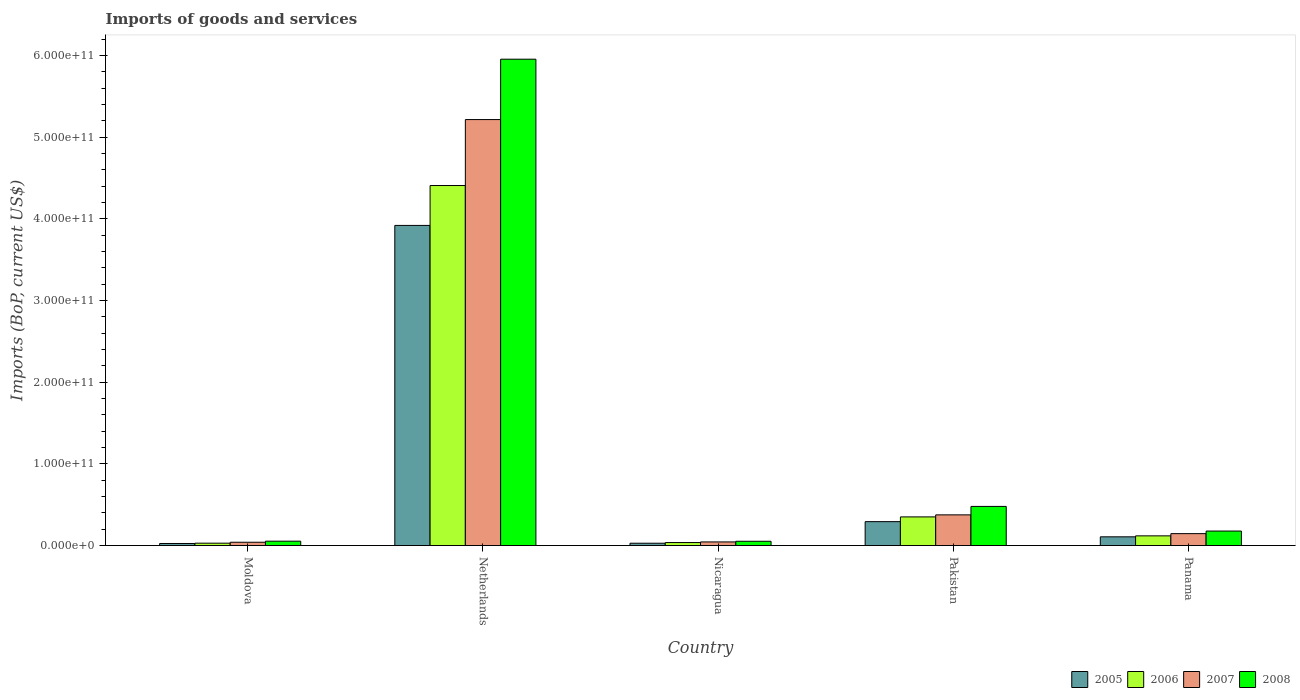How many different coloured bars are there?
Offer a very short reply. 4. How many groups of bars are there?
Your answer should be compact. 5. Are the number of bars per tick equal to the number of legend labels?
Make the answer very short. Yes. Are the number of bars on each tick of the X-axis equal?
Make the answer very short. Yes. How many bars are there on the 1st tick from the left?
Offer a very short reply. 4. What is the label of the 3rd group of bars from the left?
Give a very brief answer. Nicaragua. What is the amount spent on imports in 2007 in Nicaragua?
Provide a succinct answer. 4.45e+09. Across all countries, what is the maximum amount spent on imports in 2008?
Provide a succinct answer. 5.95e+11. Across all countries, what is the minimum amount spent on imports in 2008?
Keep it short and to the point. 5.26e+09. In which country was the amount spent on imports in 2005 minimum?
Provide a succinct answer. Moldova. What is the total amount spent on imports in 2007 in the graph?
Provide a succinct answer. 5.82e+11. What is the difference between the amount spent on imports in 2007 in Moldova and that in Netherlands?
Give a very brief answer. -5.17e+11. What is the difference between the amount spent on imports in 2005 in Netherlands and the amount spent on imports in 2006 in Pakistan?
Give a very brief answer. 3.57e+11. What is the average amount spent on imports in 2007 per country?
Make the answer very short. 1.16e+11. What is the difference between the amount spent on imports of/in 2006 and amount spent on imports of/in 2005 in Moldova?
Ensure brevity in your answer.  3.81e+08. In how many countries, is the amount spent on imports in 2007 greater than 20000000000 US$?
Your response must be concise. 2. What is the ratio of the amount spent on imports in 2007 in Nicaragua to that in Panama?
Ensure brevity in your answer.  0.3. Is the amount spent on imports in 2007 in Moldova less than that in Netherlands?
Your response must be concise. Yes. Is the difference between the amount spent on imports in 2006 in Netherlands and Pakistan greater than the difference between the amount spent on imports in 2005 in Netherlands and Pakistan?
Your answer should be compact. Yes. What is the difference between the highest and the second highest amount spent on imports in 2008?
Your answer should be very brief. 5.78e+11. What is the difference between the highest and the lowest amount spent on imports in 2008?
Your answer should be compact. 5.90e+11. In how many countries, is the amount spent on imports in 2005 greater than the average amount spent on imports in 2005 taken over all countries?
Make the answer very short. 1. Is the sum of the amount spent on imports in 2006 in Nicaragua and Pakistan greater than the maximum amount spent on imports in 2005 across all countries?
Your response must be concise. No. What does the 3rd bar from the left in Nicaragua represents?
Make the answer very short. 2007. What does the 1st bar from the right in Panama represents?
Make the answer very short. 2008. Is it the case that in every country, the sum of the amount spent on imports in 2008 and amount spent on imports in 2006 is greater than the amount spent on imports in 2007?
Ensure brevity in your answer.  Yes. Are all the bars in the graph horizontal?
Make the answer very short. No. What is the difference between two consecutive major ticks on the Y-axis?
Ensure brevity in your answer.  1.00e+11. Does the graph contain any zero values?
Offer a terse response. No. What is the title of the graph?
Make the answer very short. Imports of goods and services. Does "1979" appear as one of the legend labels in the graph?
Provide a short and direct response. No. What is the label or title of the Y-axis?
Your response must be concise. Imports (BoP, current US$). What is the Imports (BoP, current US$) of 2005 in Moldova?
Ensure brevity in your answer.  2.54e+09. What is the Imports (BoP, current US$) of 2006 in Moldova?
Provide a succinct answer. 2.93e+09. What is the Imports (BoP, current US$) of 2007 in Moldova?
Offer a terse response. 4.07e+09. What is the Imports (BoP, current US$) in 2008 in Moldova?
Provide a succinct answer. 5.37e+09. What is the Imports (BoP, current US$) of 2005 in Netherlands?
Your answer should be compact. 3.92e+11. What is the Imports (BoP, current US$) in 2006 in Netherlands?
Ensure brevity in your answer.  4.41e+11. What is the Imports (BoP, current US$) of 2007 in Netherlands?
Provide a short and direct response. 5.22e+11. What is the Imports (BoP, current US$) in 2008 in Netherlands?
Offer a terse response. 5.95e+11. What is the Imports (BoP, current US$) in 2005 in Nicaragua?
Offer a terse response. 2.85e+09. What is the Imports (BoP, current US$) in 2006 in Nicaragua?
Your answer should be compact. 3.68e+09. What is the Imports (BoP, current US$) in 2007 in Nicaragua?
Your answer should be very brief. 4.45e+09. What is the Imports (BoP, current US$) in 2008 in Nicaragua?
Offer a very short reply. 5.26e+09. What is the Imports (BoP, current US$) of 2005 in Pakistan?
Provide a short and direct response. 2.93e+1. What is the Imports (BoP, current US$) of 2006 in Pakistan?
Give a very brief answer. 3.51e+1. What is the Imports (BoP, current US$) in 2007 in Pakistan?
Provide a succinct answer. 3.76e+1. What is the Imports (BoP, current US$) of 2008 in Pakistan?
Your answer should be very brief. 4.79e+1. What is the Imports (BoP, current US$) of 2005 in Panama?
Keep it short and to the point. 1.07e+1. What is the Imports (BoP, current US$) in 2006 in Panama?
Ensure brevity in your answer.  1.19e+1. What is the Imports (BoP, current US$) of 2007 in Panama?
Offer a terse response. 1.46e+1. What is the Imports (BoP, current US$) in 2008 in Panama?
Ensure brevity in your answer.  1.78e+1. Across all countries, what is the maximum Imports (BoP, current US$) in 2005?
Provide a succinct answer. 3.92e+11. Across all countries, what is the maximum Imports (BoP, current US$) of 2006?
Keep it short and to the point. 4.41e+11. Across all countries, what is the maximum Imports (BoP, current US$) of 2007?
Give a very brief answer. 5.22e+11. Across all countries, what is the maximum Imports (BoP, current US$) in 2008?
Your answer should be compact. 5.95e+11. Across all countries, what is the minimum Imports (BoP, current US$) of 2005?
Make the answer very short. 2.54e+09. Across all countries, what is the minimum Imports (BoP, current US$) of 2006?
Your response must be concise. 2.93e+09. Across all countries, what is the minimum Imports (BoP, current US$) in 2007?
Ensure brevity in your answer.  4.07e+09. Across all countries, what is the minimum Imports (BoP, current US$) of 2008?
Provide a succinct answer. 5.26e+09. What is the total Imports (BoP, current US$) of 2005 in the graph?
Your answer should be compact. 4.37e+11. What is the total Imports (BoP, current US$) in 2006 in the graph?
Provide a short and direct response. 4.94e+11. What is the total Imports (BoP, current US$) in 2007 in the graph?
Give a very brief answer. 5.82e+11. What is the total Imports (BoP, current US$) in 2008 in the graph?
Offer a very short reply. 6.72e+11. What is the difference between the Imports (BoP, current US$) in 2005 in Moldova and that in Netherlands?
Provide a succinct answer. -3.89e+11. What is the difference between the Imports (BoP, current US$) in 2006 in Moldova and that in Netherlands?
Make the answer very short. -4.38e+11. What is the difference between the Imports (BoP, current US$) of 2007 in Moldova and that in Netherlands?
Your response must be concise. -5.17e+11. What is the difference between the Imports (BoP, current US$) of 2008 in Moldova and that in Netherlands?
Your answer should be compact. -5.90e+11. What is the difference between the Imports (BoP, current US$) of 2005 in Moldova and that in Nicaragua?
Your answer should be compact. -3.08e+08. What is the difference between the Imports (BoP, current US$) in 2006 in Moldova and that in Nicaragua?
Offer a terse response. -7.55e+08. What is the difference between the Imports (BoP, current US$) of 2007 in Moldova and that in Nicaragua?
Offer a terse response. -3.85e+08. What is the difference between the Imports (BoP, current US$) of 2008 in Moldova and that in Nicaragua?
Offer a terse response. 1.14e+08. What is the difference between the Imports (BoP, current US$) in 2005 in Moldova and that in Pakistan?
Provide a short and direct response. -2.67e+1. What is the difference between the Imports (BoP, current US$) of 2006 in Moldova and that in Pakistan?
Give a very brief answer. -3.22e+1. What is the difference between the Imports (BoP, current US$) of 2007 in Moldova and that in Pakistan?
Your answer should be very brief. -3.35e+1. What is the difference between the Imports (BoP, current US$) of 2008 in Moldova and that in Pakistan?
Give a very brief answer. -4.26e+1. What is the difference between the Imports (BoP, current US$) in 2005 in Moldova and that in Panama?
Make the answer very short. -8.16e+09. What is the difference between the Imports (BoP, current US$) in 2006 in Moldova and that in Panama?
Your response must be concise. -8.96e+09. What is the difference between the Imports (BoP, current US$) in 2007 in Moldova and that in Panama?
Offer a very short reply. -1.05e+1. What is the difference between the Imports (BoP, current US$) of 2008 in Moldova and that in Panama?
Offer a terse response. -1.24e+1. What is the difference between the Imports (BoP, current US$) of 2005 in Netherlands and that in Nicaragua?
Make the answer very short. 3.89e+11. What is the difference between the Imports (BoP, current US$) of 2006 in Netherlands and that in Nicaragua?
Your response must be concise. 4.37e+11. What is the difference between the Imports (BoP, current US$) in 2007 in Netherlands and that in Nicaragua?
Provide a succinct answer. 5.17e+11. What is the difference between the Imports (BoP, current US$) of 2008 in Netherlands and that in Nicaragua?
Provide a succinct answer. 5.90e+11. What is the difference between the Imports (BoP, current US$) of 2005 in Netherlands and that in Pakistan?
Keep it short and to the point. 3.63e+11. What is the difference between the Imports (BoP, current US$) of 2006 in Netherlands and that in Pakistan?
Offer a terse response. 4.06e+11. What is the difference between the Imports (BoP, current US$) of 2007 in Netherlands and that in Pakistan?
Provide a short and direct response. 4.84e+11. What is the difference between the Imports (BoP, current US$) in 2008 in Netherlands and that in Pakistan?
Make the answer very short. 5.48e+11. What is the difference between the Imports (BoP, current US$) of 2005 in Netherlands and that in Panama?
Your answer should be very brief. 3.81e+11. What is the difference between the Imports (BoP, current US$) in 2006 in Netherlands and that in Panama?
Your answer should be compact. 4.29e+11. What is the difference between the Imports (BoP, current US$) in 2007 in Netherlands and that in Panama?
Ensure brevity in your answer.  5.07e+11. What is the difference between the Imports (BoP, current US$) of 2008 in Netherlands and that in Panama?
Offer a terse response. 5.78e+11. What is the difference between the Imports (BoP, current US$) of 2005 in Nicaragua and that in Pakistan?
Your answer should be very brief. -2.64e+1. What is the difference between the Imports (BoP, current US$) of 2006 in Nicaragua and that in Pakistan?
Your answer should be very brief. -3.14e+1. What is the difference between the Imports (BoP, current US$) in 2007 in Nicaragua and that in Pakistan?
Your answer should be very brief. -3.31e+1. What is the difference between the Imports (BoP, current US$) of 2008 in Nicaragua and that in Pakistan?
Provide a short and direct response. -4.27e+1. What is the difference between the Imports (BoP, current US$) in 2005 in Nicaragua and that in Panama?
Offer a terse response. -7.85e+09. What is the difference between the Imports (BoP, current US$) of 2006 in Nicaragua and that in Panama?
Provide a succinct answer. -8.20e+09. What is the difference between the Imports (BoP, current US$) of 2007 in Nicaragua and that in Panama?
Your response must be concise. -1.02e+1. What is the difference between the Imports (BoP, current US$) of 2008 in Nicaragua and that in Panama?
Your answer should be very brief. -1.25e+1. What is the difference between the Imports (BoP, current US$) in 2005 in Pakistan and that in Panama?
Ensure brevity in your answer.  1.86e+1. What is the difference between the Imports (BoP, current US$) in 2006 in Pakistan and that in Panama?
Provide a short and direct response. 2.32e+1. What is the difference between the Imports (BoP, current US$) of 2007 in Pakistan and that in Panama?
Offer a terse response. 2.30e+1. What is the difference between the Imports (BoP, current US$) in 2008 in Pakistan and that in Panama?
Give a very brief answer. 3.02e+1. What is the difference between the Imports (BoP, current US$) in 2005 in Moldova and the Imports (BoP, current US$) in 2006 in Netherlands?
Offer a terse response. -4.38e+11. What is the difference between the Imports (BoP, current US$) in 2005 in Moldova and the Imports (BoP, current US$) in 2007 in Netherlands?
Provide a succinct answer. -5.19e+11. What is the difference between the Imports (BoP, current US$) of 2005 in Moldova and the Imports (BoP, current US$) of 2008 in Netherlands?
Offer a terse response. -5.93e+11. What is the difference between the Imports (BoP, current US$) of 2006 in Moldova and the Imports (BoP, current US$) of 2007 in Netherlands?
Ensure brevity in your answer.  -5.19e+11. What is the difference between the Imports (BoP, current US$) of 2006 in Moldova and the Imports (BoP, current US$) of 2008 in Netherlands?
Your response must be concise. -5.93e+11. What is the difference between the Imports (BoP, current US$) of 2007 in Moldova and the Imports (BoP, current US$) of 2008 in Netherlands?
Your response must be concise. -5.91e+11. What is the difference between the Imports (BoP, current US$) of 2005 in Moldova and the Imports (BoP, current US$) of 2006 in Nicaragua?
Your answer should be compact. -1.14e+09. What is the difference between the Imports (BoP, current US$) of 2005 in Moldova and the Imports (BoP, current US$) of 2007 in Nicaragua?
Offer a terse response. -1.91e+09. What is the difference between the Imports (BoP, current US$) in 2005 in Moldova and the Imports (BoP, current US$) in 2008 in Nicaragua?
Keep it short and to the point. -2.71e+09. What is the difference between the Imports (BoP, current US$) of 2006 in Moldova and the Imports (BoP, current US$) of 2007 in Nicaragua?
Your answer should be compact. -1.53e+09. What is the difference between the Imports (BoP, current US$) of 2006 in Moldova and the Imports (BoP, current US$) of 2008 in Nicaragua?
Offer a very short reply. -2.33e+09. What is the difference between the Imports (BoP, current US$) in 2007 in Moldova and the Imports (BoP, current US$) in 2008 in Nicaragua?
Your response must be concise. -1.19e+09. What is the difference between the Imports (BoP, current US$) in 2005 in Moldova and the Imports (BoP, current US$) in 2006 in Pakistan?
Provide a succinct answer. -3.26e+1. What is the difference between the Imports (BoP, current US$) in 2005 in Moldova and the Imports (BoP, current US$) in 2007 in Pakistan?
Offer a very short reply. -3.50e+1. What is the difference between the Imports (BoP, current US$) of 2005 in Moldova and the Imports (BoP, current US$) of 2008 in Pakistan?
Your response must be concise. -4.54e+1. What is the difference between the Imports (BoP, current US$) of 2006 in Moldova and the Imports (BoP, current US$) of 2007 in Pakistan?
Your answer should be very brief. -3.47e+1. What is the difference between the Imports (BoP, current US$) in 2006 in Moldova and the Imports (BoP, current US$) in 2008 in Pakistan?
Provide a short and direct response. -4.50e+1. What is the difference between the Imports (BoP, current US$) in 2007 in Moldova and the Imports (BoP, current US$) in 2008 in Pakistan?
Your answer should be very brief. -4.39e+1. What is the difference between the Imports (BoP, current US$) of 2005 in Moldova and the Imports (BoP, current US$) of 2006 in Panama?
Keep it short and to the point. -9.34e+09. What is the difference between the Imports (BoP, current US$) of 2005 in Moldova and the Imports (BoP, current US$) of 2007 in Panama?
Your answer should be very brief. -1.21e+1. What is the difference between the Imports (BoP, current US$) in 2005 in Moldova and the Imports (BoP, current US$) in 2008 in Panama?
Give a very brief answer. -1.52e+1. What is the difference between the Imports (BoP, current US$) of 2006 in Moldova and the Imports (BoP, current US$) of 2007 in Panama?
Offer a very short reply. -1.17e+1. What is the difference between the Imports (BoP, current US$) of 2006 in Moldova and the Imports (BoP, current US$) of 2008 in Panama?
Provide a succinct answer. -1.48e+1. What is the difference between the Imports (BoP, current US$) in 2007 in Moldova and the Imports (BoP, current US$) in 2008 in Panama?
Your answer should be very brief. -1.37e+1. What is the difference between the Imports (BoP, current US$) in 2005 in Netherlands and the Imports (BoP, current US$) in 2006 in Nicaragua?
Provide a succinct answer. 3.88e+11. What is the difference between the Imports (BoP, current US$) of 2005 in Netherlands and the Imports (BoP, current US$) of 2007 in Nicaragua?
Make the answer very short. 3.87e+11. What is the difference between the Imports (BoP, current US$) in 2005 in Netherlands and the Imports (BoP, current US$) in 2008 in Nicaragua?
Offer a very short reply. 3.87e+11. What is the difference between the Imports (BoP, current US$) in 2006 in Netherlands and the Imports (BoP, current US$) in 2007 in Nicaragua?
Your answer should be very brief. 4.36e+11. What is the difference between the Imports (BoP, current US$) of 2006 in Netherlands and the Imports (BoP, current US$) of 2008 in Nicaragua?
Keep it short and to the point. 4.36e+11. What is the difference between the Imports (BoP, current US$) in 2007 in Netherlands and the Imports (BoP, current US$) in 2008 in Nicaragua?
Ensure brevity in your answer.  5.16e+11. What is the difference between the Imports (BoP, current US$) of 2005 in Netherlands and the Imports (BoP, current US$) of 2006 in Pakistan?
Your answer should be very brief. 3.57e+11. What is the difference between the Imports (BoP, current US$) of 2005 in Netherlands and the Imports (BoP, current US$) of 2007 in Pakistan?
Your answer should be compact. 3.54e+11. What is the difference between the Imports (BoP, current US$) of 2005 in Netherlands and the Imports (BoP, current US$) of 2008 in Pakistan?
Provide a succinct answer. 3.44e+11. What is the difference between the Imports (BoP, current US$) in 2006 in Netherlands and the Imports (BoP, current US$) in 2007 in Pakistan?
Ensure brevity in your answer.  4.03e+11. What is the difference between the Imports (BoP, current US$) of 2006 in Netherlands and the Imports (BoP, current US$) of 2008 in Pakistan?
Make the answer very short. 3.93e+11. What is the difference between the Imports (BoP, current US$) of 2007 in Netherlands and the Imports (BoP, current US$) of 2008 in Pakistan?
Ensure brevity in your answer.  4.74e+11. What is the difference between the Imports (BoP, current US$) of 2005 in Netherlands and the Imports (BoP, current US$) of 2006 in Panama?
Your answer should be very brief. 3.80e+11. What is the difference between the Imports (BoP, current US$) of 2005 in Netherlands and the Imports (BoP, current US$) of 2007 in Panama?
Your answer should be very brief. 3.77e+11. What is the difference between the Imports (BoP, current US$) of 2005 in Netherlands and the Imports (BoP, current US$) of 2008 in Panama?
Ensure brevity in your answer.  3.74e+11. What is the difference between the Imports (BoP, current US$) in 2006 in Netherlands and the Imports (BoP, current US$) in 2007 in Panama?
Give a very brief answer. 4.26e+11. What is the difference between the Imports (BoP, current US$) of 2006 in Netherlands and the Imports (BoP, current US$) of 2008 in Panama?
Offer a very short reply. 4.23e+11. What is the difference between the Imports (BoP, current US$) in 2007 in Netherlands and the Imports (BoP, current US$) in 2008 in Panama?
Make the answer very short. 5.04e+11. What is the difference between the Imports (BoP, current US$) of 2005 in Nicaragua and the Imports (BoP, current US$) of 2006 in Pakistan?
Give a very brief answer. -3.22e+1. What is the difference between the Imports (BoP, current US$) in 2005 in Nicaragua and the Imports (BoP, current US$) in 2007 in Pakistan?
Give a very brief answer. -3.47e+1. What is the difference between the Imports (BoP, current US$) of 2005 in Nicaragua and the Imports (BoP, current US$) of 2008 in Pakistan?
Give a very brief answer. -4.51e+1. What is the difference between the Imports (BoP, current US$) in 2006 in Nicaragua and the Imports (BoP, current US$) in 2007 in Pakistan?
Keep it short and to the point. -3.39e+1. What is the difference between the Imports (BoP, current US$) in 2006 in Nicaragua and the Imports (BoP, current US$) in 2008 in Pakistan?
Provide a short and direct response. -4.42e+1. What is the difference between the Imports (BoP, current US$) in 2007 in Nicaragua and the Imports (BoP, current US$) in 2008 in Pakistan?
Provide a short and direct response. -4.35e+1. What is the difference between the Imports (BoP, current US$) in 2005 in Nicaragua and the Imports (BoP, current US$) in 2006 in Panama?
Make the answer very short. -9.03e+09. What is the difference between the Imports (BoP, current US$) in 2005 in Nicaragua and the Imports (BoP, current US$) in 2007 in Panama?
Provide a succinct answer. -1.18e+1. What is the difference between the Imports (BoP, current US$) in 2005 in Nicaragua and the Imports (BoP, current US$) in 2008 in Panama?
Make the answer very short. -1.49e+1. What is the difference between the Imports (BoP, current US$) in 2006 in Nicaragua and the Imports (BoP, current US$) in 2007 in Panama?
Provide a short and direct response. -1.09e+1. What is the difference between the Imports (BoP, current US$) in 2006 in Nicaragua and the Imports (BoP, current US$) in 2008 in Panama?
Make the answer very short. -1.41e+1. What is the difference between the Imports (BoP, current US$) of 2007 in Nicaragua and the Imports (BoP, current US$) of 2008 in Panama?
Your response must be concise. -1.33e+1. What is the difference between the Imports (BoP, current US$) of 2005 in Pakistan and the Imports (BoP, current US$) of 2006 in Panama?
Offer a very short reply. 1.74e+1. What is the difference between the Imports (BoP, current US$) in 2005 in Pakistan and the Imports (BoP, current US$) in 2007 in Panama?
Your answer should be compact. 1.47e+1. What is the difference between the Imports (BoP, current US$) in 2005 in Pakistan and the Imports (BoP, current US$) in 2008 in Panama?
Offer a very short reply. 1.15e+1. What is the difference between the Imports (BoP, current US$) of 2006 in Pakistan and the Imports (BoP, current US$) of 2007 in Panama?
Offer a very short reply. 2.05e+1. What is the difference between the Imports (BoP, current US$) in 2006 in Pakistan and the Imports (BoP, current US$) in 2008 in Panama?
Ensure brevity in your answer.  1.73e+1. What is the difference between the Imports (BoP, current US$) in 2007 in Pakistan and the Imports (BoP, current US$) in 2008 in Panama?
Give a very brief answer. 1.98e+1. What is the average Imports (BoP, current US$) in 2005 per country?
Ensure brevity in your answer.  8.75e+1. What is the average Imports (BoP, current US$) of 2006 per country?
Your response must be concise. 9.89e+1. What is the average Imports (BoP, current US$) in 2007 per country?
Your answer should be very brief. 1.16e+11. What is the average Imports (BoP, current US$) in 2008 per country?
Give a very brief answer. 1.34e+11. What is the difference between the Imports (BoP, current US$) of 2005 and Imports (BoP, current US$) of 2006 in Moldova?
Your answer should be compact. -3.81e+08. What is the difference between the Imports (BoP, current US$) in 2005 and Imports (BoP, current US$) in 2007 in Moldova?
Give a very brief answer. -1.52e+09. What is the difference between the Imports (BoP, current US$) in 2005 and Imports (BoP, current US$) in 2008 in Moldova?
Provide a short and direct response. -2.82e+09. What is the difference between the Imports (BoP, current US$) in 2006 and Imports (BoP, current US$) in 2007 in Moldova?
Offer a terse response. -1.14e+09. What is the difference between the Imports (BoP, current US$) in 2006 and Imports (BoP, current US$) in 2008 in Moldova?
Provide a short and direct response. -2.44e+09. What is the difference between the Imports (BoP, current US$) in 2007 and Imports (BoP, current US$) in 2008 in Moldova?
Your answer should be very brief. -1.30e+09. What is the difference between the Imports (BoP, current US$) of 2005 and Imports (BoP, current US$) of 2006 in Netherlands?
Make the answer very short. -4.88e+1. What is the difference between the Imports (BoP, current US$) in 2005 and Imports (BoP, current US$) in 2007 in Netherlands?
Give a very brief answer. -1.30e+11. What is the difference between the Imports (BoP, current US$) of 2005 and Imports (BoP, current US$) of 2008 in Netherlands?
Provide a short and direct response. -2.04e+11. What is the difference between the Imports (BoP, current US$) in 2006 and Imports (BoP, current US$) in 2007 in Netherlands?
Your response must be concise. -8.07e+1. What is the difference between the Imports (BoP, current US$) of 2006 and Imports (BoP, current US$) of 2008 in Netherlands?
Provide a succinct answer. -1.55e+11. What is the difference between the Imports (BoP, current US$) of 2007 and Imports (BoP, current US$) of 2008 in Netherlands?
Provide a succinct answer. -7.39e+1. What is the difference between the Imports (BoP, current US$) of 2005 and Imports (BoP, current US$) of 2006 in Nicaragua?
Offer a terse response. -8.28e+08. What is the difference between the Imports (BoP, current US$) of 2005 and Imports (BoP, current US$) of 2007 in Nicaragua?
Provide a succinct answer. -1.60e+09. What is the difference between the Imports (BoP, current US$) of 2005 and Imports (BoP, current US$) of 2008 in Nicaragua?
Your answer should be compact. -2.40e+09. What is the difference between the Imports (BoP, current US$) in 2006 and Imports (BoP, current US$) in 2007 in Nicaragua?
Offer a terse response. -7.70e+08. What is the difference between the Imports (BoP, current US$) of 2006 and Imports (BoP, current US$) of 2008 in Nicaragua?
Keep it short and to the point. -1.57e+09. What is the difference between the Imports (BoP, current US$) in 2007 and Imports (BoP, current US$) in 2008 in Nicaragua?
Your response must be concise. -8.05e+08. What is the difference between the Imports (BoP, current US$) in 2005 and Imports (BoP, current US$) in 2006 in Pakistan?
Ensure brevity in your answer.  -5.83e+09. What is the difference between the Imports (BoP, current US$) of 2005 and Imports (BoP, current US$) of 2007 in Pakistan?
Make the answer very short. -8.31e+09. What is the difference between the Imports (BoP, current US$) in 2005 and Imports (BoP, current US$) in 2008 in Pakistan?
Offer a very short reply. -1.87e+1. What is the difference between the Imports (BoP, current US$) in 2006 and Imports (BoP, current US$) in 2007 in Pakistan?
Provide a succinct answer. -2.49e+09. What is the difference between the Imports (BoP, current US$) of 2006 and Imports (BoP, current US$) of 2008 in Pakistan?
Keep it short and to the point. -1.28e+1. What is the difference between the Imports (BoP, current US$) of 2007 and Imports (BoP, current US$) of 2008 in Pakistan?
Make the answer very short. -1.03e+1. What is the difference between the Imports (BoP, current US$) of 2005 and Imports (BoP, current US$) of 2006 in Panama?
Offer a terse response. -1.18e+09. What is the difference between the Imports (BoP, current US$) in 2005 and Imports (BoP, current US$) in 2007 in Panama?
Your response must be concise. -3.91e+09. What is the difference between the Imports (BoP, current US$) in 2005 and Imports (BoP, current US$) in 2008 in Panama?
Your answer should be very brief. -7.06e+09. What is the difference between the Imports (BoP, current US$) in 2006 and Imports (BoP, current US$) in 2007 in Panama?
Your answer should be compact. -2.73e+09. What is the difference between the Imports (BoP, current US$) in 2006 and Imports (BoP, current US$) in 2008 in Panama?
Give a very brief answer. -5.87e+09. What is the difference between the Imports (BoP, current US$) of 2007 and Imports (BoP, current US$) of 2008 in Panama?
Give a very brief answer. -3.14e+09. What is the ratio of the Imports (BoP, current US$) in 2005 in Moldova to that in Netherlands?
Your answer should be compact. 0.01. What is the ratio of the Imports (BoP, current US$) of 2006 in Moldova to that in Netherlands?
Provide a succinct answer. 0.01. What is the ratio of the Imports (BoP, current US$) in 2007 in Moldova to that in Netherlands?
Your answer should be compact. 0.01. What is the ratio of the Imports (BoP, current US$) of 2008 in Moldova to that in Netherlands?
Ensure brevity in your answer.  0.01. What is the ratio of the Imports (BoP, current US$) in 2005 in Moldova to that in Nicaragua?
Your answer should be compact. 0.89. What is the ratio of the Imports (BoP, current US$) in 2006 in Moldova to that in Nicaragua?
Ensure brevity in your answer.  0.79. What is the ratio of the Imports (BoP, current US$) of 2007 in Moldova to that in Nicaragua?
Give a very brief answer. 0.91. What is the ratio of the Imports (BoP, current US$) of 2008 in Moldova to that in Nicaragua?
Your answer should be very brief. 1.02. What is the ratio of the Imports (BoP, current US$) in 2005 in Moldova to that in Pakistan?
Your answer should be very brief. 0.09. What is the ratio of the Imports (BoP, current US$) of 2006 in Moldova to that in Pakistan?
Your answer should be compact. 0.08. What is the ratio of the Imports (BoP, current US$) in 2007 in Moldova to that in Pakistan?
Your answer should be very brief. 0.11. What is the ratio of the Imports (BoP, current US$) in 2008 in Moldova to that in Pakistan?
Your response must be concise. 0.11. What is the ratio of the Imports (BoP, current US$) of 2005 in Moldova to that in Panama?
Ensure brevity in your answer.  0.24. What is the ratio of the Imports (BoP, current US$) in 2006 in Moldova to that in Panama?
Give a very brief answer. 0.25. What is the ratio of the Imports (BoP, current US$) in 2007 in Moldova to that in Panama?
Your response must be concise. 0.28. What is the ratio of the Imports (BoP, current US$) in 2008 in Moldova to that in Panama?
Offer a terse response. 0.3. What is the ratio of the Imports (BoP, current US$) of 2005 in Netherlands to that in Nicaragua?
Your answer should be very brief. 137.38. What is the ratio of the Imports (BoP, current US$) of 2006 in Netherlands to that in Nicaragua?
Ensure brevity in your answer.  119.75. What is the ratio of the Imports (BoP, current US$) in 2007 in Netherlands to that in Nicaragua?
Offer a very short reply. 117.17. What is the ratio of the Imports (BoP, current US$) in 2008 in Netherlands to that in Nicaragua?
Make the answer very short. 113.3. What is the ratio of the Imports (BoP, current US$) in 2005 in Netherlands to that in Pakistan?
Offer a terse response. 13.39. What is the ratio of the Imports (BoP, current US$) of 2006 in Netherlands to that in Pakistan?
Your response must be concise. 12.56. What is the ratio of the Imports (BoP, current US$) of 2007 in Netherlands to that in Pakistan?
Keep it short and to the point. 13.88. What is the ratio of the Imports (BoP, current US$) of 2008 in Netherlands to that in Pakistan?
Make the answer very short. 12.42. What is the ratio of the Imports (BoP, current US$) of 2005 in Netherlands to that in Panama?
Your answer should be very brief. 36.62. What is the ratio of the Imports (BoP, current US$) of 2006 in Netherlands to that in Panama?
Your response must be concise. 37.08. What is the ratio of the Imports (BoP, current US$) in 2007 in Netherlands to that in Panama?
Offer a very short reply. 35.69. What is the ratio of the Imports (BoP, current US$) of 2008 in Netherlands to that in Panama?
Your answer should be very brief. 33.53. What is the ratio of the Imports (BoP, current US$) in 2005 in Nicaragua to that in Pakistan?
Ensure brevity in your answer.  0.1. What is the ratio of the Imports (BoP, current US$) in 2006 in Nicaragua to that in Pakistan?
Provide a short and direct response. 0.1. What is the ratio of the Imports (BoP, current US$) in 2007 in Nicaragua to that in Pakistan?
Provide a succinct answer. 0.12. What is the ratio of the Imports (BoP, current US$) of 2008 in Nicaragua to that in Pakistan?
Offer a very short reply. 0.11. What is the ratio of the Imports (BoP, current US$) in 2005 in Nicaragua to that in Panama?
Offer a terse response. 0.27. What is the ratio of the Imports (BoP, current US$) in 2006 in Nicaragua to that in Panama?
Your answer should be compact. 0.31. What is the ratio of the Imports (BoP, current US$) of 2007 in Nicaragua to that in Panama?
Your answer should be very brief. 0.3. What is the ratio of the Imports (BoP, current US$) in 2008 in Nicaragua to that in Panama?
Provide a short and direct response. 0.3. What is the ratio of the Imports (BoP, current US$) in 2005 in Pakistan to that in Panama?
Offer a terse response. 2.74. What is the ratio of the Imports (BoP, current US$) of 2006 in Pakistan to that in Panama?
Make the answer very short. 2.95. What is the ratio of the Imports (BoP, current US$) in 2007 in Pakistan to that in Panama?
Make the answer very short. 2.57. What is the ratio of the Imports (BoP, current US$) of 2008 in Pakistan to that in Panama?
Your response must be concise. 2.7. What is the difference between the highest and the second highest Imports (BoP, current US$) in 2005?
Make the answer very short. 3.63e+11. What is the difference between the highest and the second highest Imports (BoP, current US$) in 2006?
Your answer should be very brief. 4.06e+11. What is the difference between the highest and the second highest Imports (BoP, current US$) in 2007?
Provide a short and direct response. 4.84e+11. What is the difference between the highest and the second highest Imports (BoP, current US$) of 2008?
Your response must be concise. 5.48e+11. What is the difference between the highest and the lowest Imports (BoP, current US$) of 2005?
Offer a terse response. 3.89e+11. What is the difference between the highest and the lowest Imports (BoP, current US$) of 2006?
Keep it short and to the point. 4.38e+11. What is the difference between the highest and the lowest Imports (BoP, current US$) of 2007?
Make the answer very short. 5.17e+11. What is the difference between the highest and the lowest Imports (BoP, current US$) of 2008?
Keep it short and to the point. 5.90e+11. 